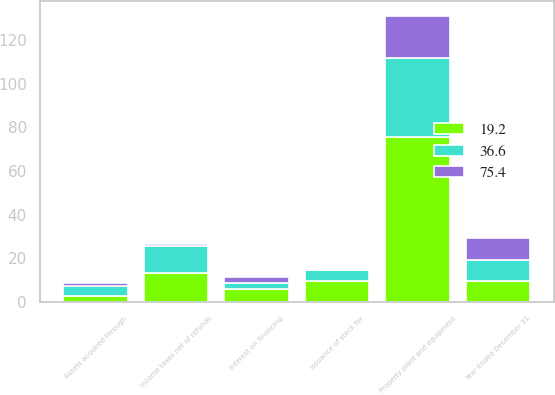<chart> <loc_0><loc_0><loc_500><loc_500><stacked_bar_chart><ecel><fcel>Year Ended December 31<fcel>Interest on financing<fcel>Income taxes net of refunds<fcel>Property plant and equipment<fcel>Issuance of stock for<fcel>Assets acquired through<nl><fcel>75.4<fcel>9.7<fcel>2.3<fcel>0.9<fcel>19.2<fcel>0.5<fcel>1.2<nl><fcel>36.6<fcel>9.7<fcel>3.1<fcel>12.7<fcel>36.6<fcel>5.1<fcel>4.8<nl><fcel>19.2<fcel>9.7<fcel>5.8<fcel>13.1<fcel>75.4<fcel>9.7<fcel>2.7<nl></chart> 